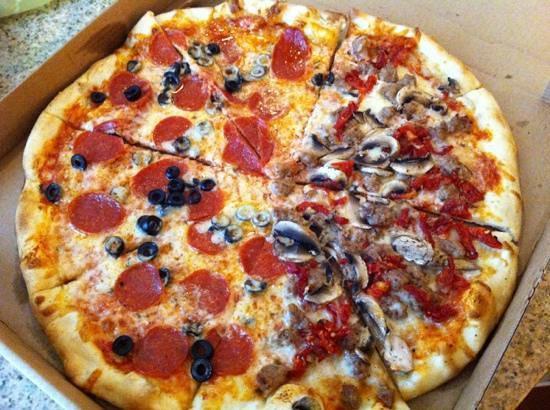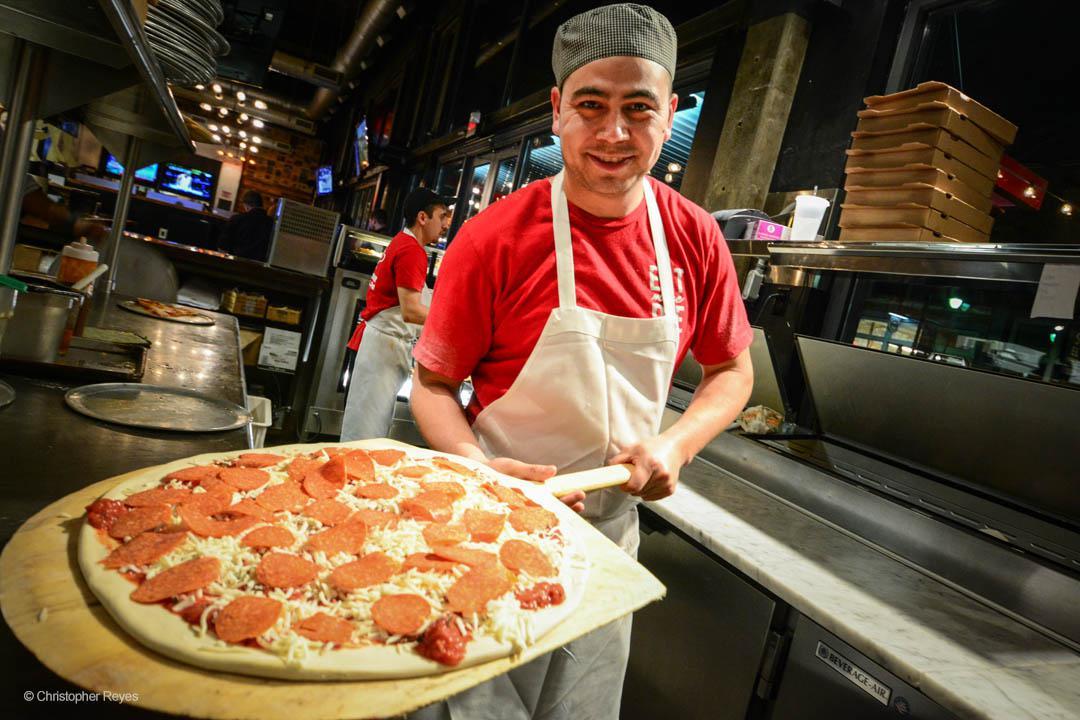The first image is the image on the left, the second image is the image on the right. For the images shown, is this caption "The pizza in the image on the left is sitting in a cardboard box." true? Answer yes or no. Yes. The first image is the image on the left, the second image is the image on the right. Examine the images to the left and right. Is the description "There are two pizzas with one still in a cardboard box." accurate? Answer yes or no. Yes. 